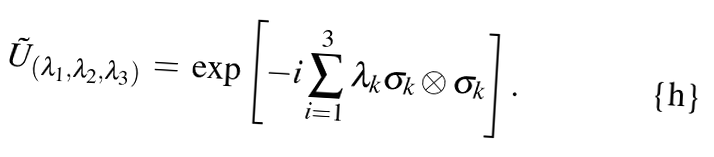<formula> <loc_0><loc_0><loc_500><loc_500>\tilde { U } _ { ( \lambda _ { 1 } , \lambda _ { 2 } , \lambda _ { 3 } ) } \, = \, \exp \left [ - i \sum _ { i = 1 } ^ { 3 } \lambda _ { k } \sigma _ { k } \otimes \sigma _ { k } \right ] .</formula> 